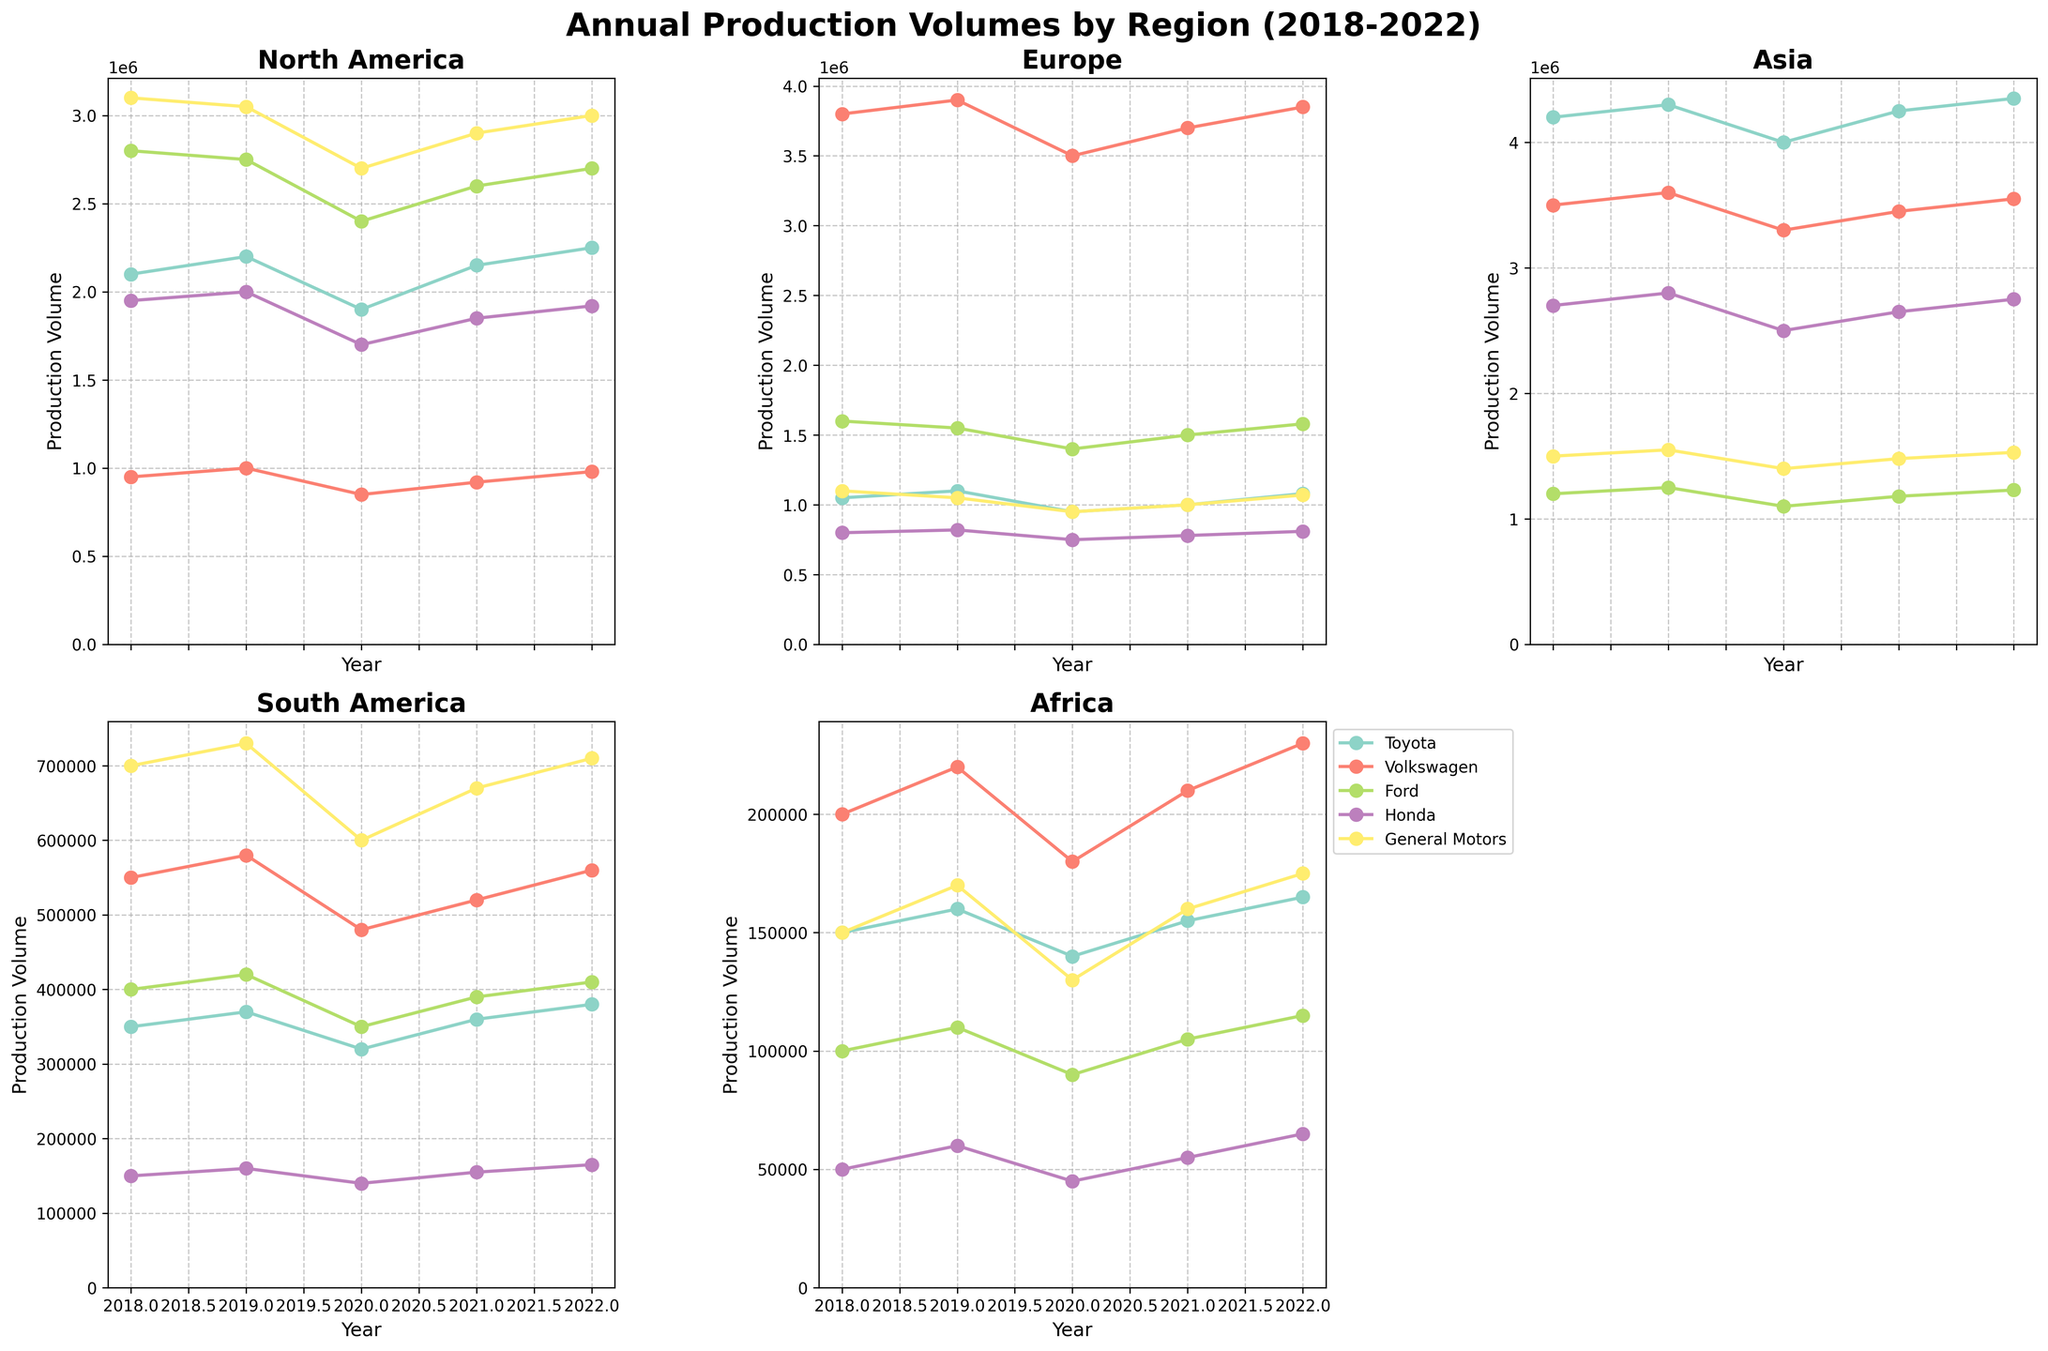Which manufacturer had the highest production volume in Asia in 2022? By looking at the subplot for Asia and checking the 2022 data point for each manufacturer, Toyota shows the highest production volume in Asia.
Answer: Toyota Which two regions had the highest production volumes for Ford in 2021? By examining the subplots and comparing the data points for Ford in 2021, North America and Europe had the highest production volumes.
Answer: North America and Europe What's the average annual production volume for Honda in South America from 2018 to 2022? Summing the production volumes for Honda in South America across the years (2018 to 2022): 150,000 + 160,000 + 140,000 + 155,000 + 165,000 = 770,000. Then, divide by 5 years: 770,000 / 5 = 154,000.
Answer: 154,000 Which region shows a declining trend for General Motors from 2018 to 2020? By examining the subplots and observing the trend lines for General Motors, Europe shows a declining trend from 2018 to 2020.
Answer: Europe Which manufacturer had the most consistent production volume in Africa over the years 2018 to 2022? By looking at the subplot for Africa and comparing the production volumes' fluctuations, Honda shows the most consistent production volume with minor annual changes.
Answer: Honda In which region did Toyota see the largest increase in production volume from 2020 to 2022? By checking the increase in Toyota's production volumes between 2020 and 2022 across all subplots, Asia showed the largest increase from 4,000,000 to 4,350,000.
Answer: Asia Which year had the highest total production volume for Volkswagen across all regions? Summing Volkswagen's production volumes for each year across all regions and comparing the totals, 2019 had the highest total (1000000 + 3900000 + 3600000 + 580000 + 220000 = 9300000).
Answer: 2019 Among all regions, which one had the lowest production volume for all manufacturers combined in 2021? By comparing the total production volumes for each region for all manufacturers in 2021, Africa had the lowest combined production volume.
Answer: Africa How does Ford's production volume change in Europe from 2018 to 2022? Observing the subplot for Europe, Ford's production volume fluctuates from 1,600,000 in 2018, slightly decreasing to 1,550,000 in 2019, decreasing further to 1,400,000 in 2020, rising to 1,500,000 in 2021, and finally increasing to 1,580,000 in 2022.
Answer: Fluctuates with a final increase Which two manufacturers had the closest production volumes in North America in 2022? By comparing the North America data points for 2022, Ford (2,700,000) and General Motors (3,000,000) had the closest production volumes.
Answer: Ford and General Motors 